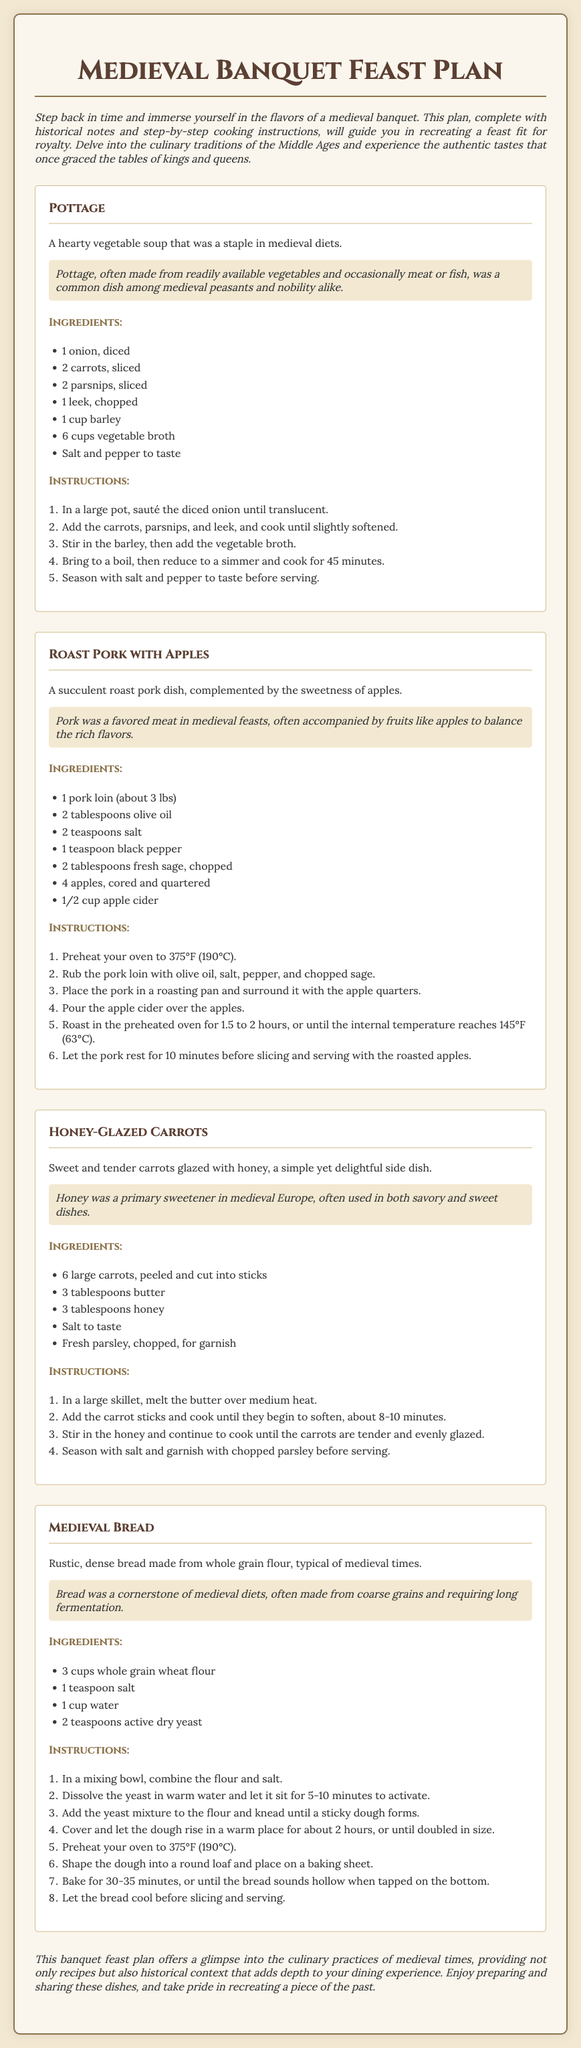What is the first dish listed in the feast plan? The first dish listed is Pottage, presented at the beginning of the recipe section.
Answer: Pottage How many cups of vegetable broth are needed for the Pottage? The ingredients section for Pottage specifies 6 cups of vegetable broth.
Answer: 6 cups What type of meat is used in the Roast Pork dish? The recipe for Roast Pork specifies that it uses pork loin, which is mentioned in the ingredients.
Answer: Pork loin How long should the Medieval Bread dough rise? The instructions for Medieval Bread state that the dough should rise for about 2 hours.
Answer: 2 hours What sweetener is mentioned in the Honey-Glazed Carrots recipe? The historical notes for Honey-Glazed Carrots highlight honey as a primary sweetener in medieval Europe.
Answer: Honey In what temperature is the oven preheated for Roast Pork? The instructions for Roast Pork specify that the oven should be preheated to 375°F (190°C).
Answer: 375°F Why was Pottage common among both peasants and nobility? The historical notes indicate that Pottage was made from readily available vegetables and occasionally meat or fish, making it accessible to all social classes.
Answer: Accessible ingredients What garnish is recommended for the Honey-Glazed Carrots? The ingredients section recommends fresh parsley, chopped, as a garnish for the carrots.
Answer: Fresh parsley What is the cooking time for the Honey-Glazed Carrots? The instructions state that the carrots should cook for about 8-10 minutes until they begin to soften.
Answer: 8-10 minutes 